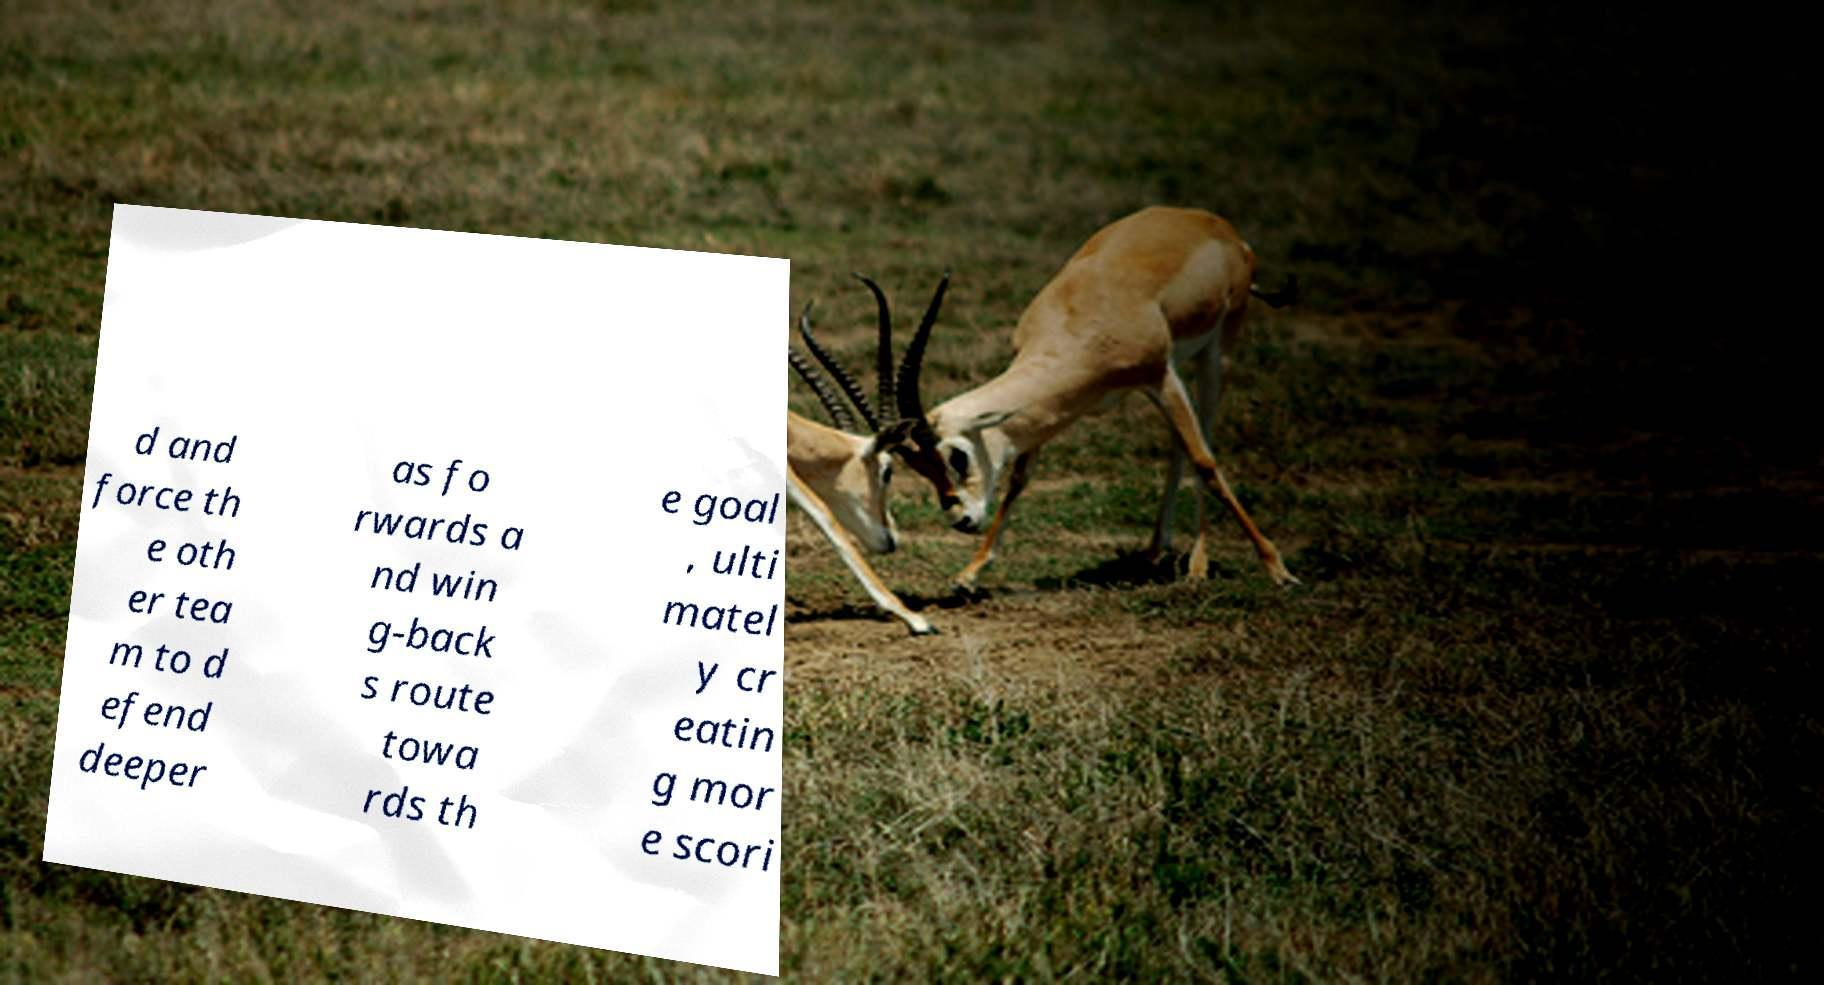Please read and relay the text visible in this image. What does it say? d and force th e oth er tea m to d efend deeper as fo rwards a nd win g-back s route towa rds th e goal , ulti matel y cr eatin g mor e scori 